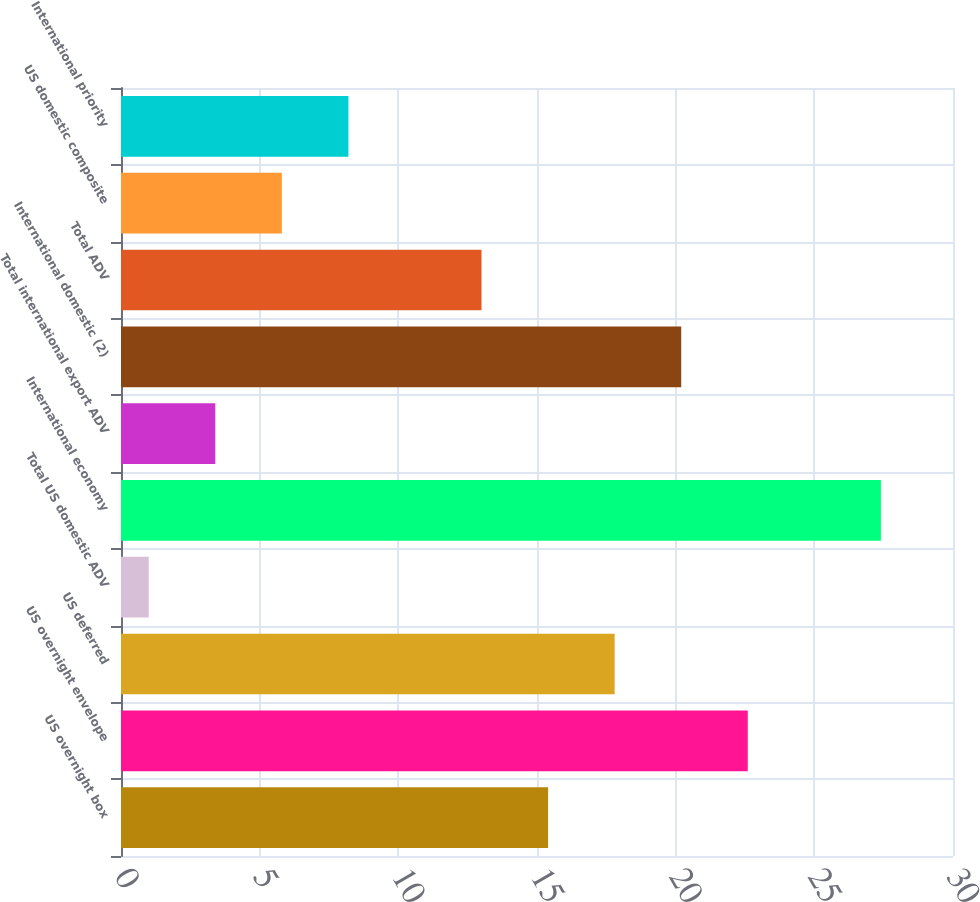Convert chart. <chart><loc_0><loc_0><loc_500><loc_500><bar_chart><fcel>US overnight box<fcel>US overnight envelope<fcel>US deferred<fcel>Total US domestic ADV<fcel>International economy<fcel>Total international export ADV<fcel>International domestic (2)<fcel>Total ADV<fcel>US domestic composite<fcel>International priority<nl><fcel>15.4<fcel>22.6<fcel>17.8<fcel>1<fcel>27.4<fcel>3.4<fcel>20.2<fcel>13<fcel>5.8<fcel>8.2<nl></chart> 